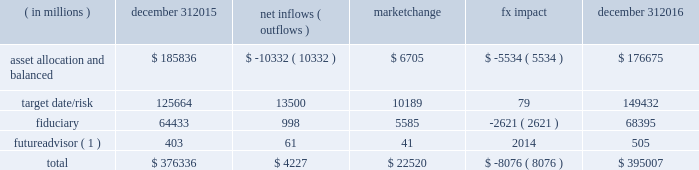Long-term product offerings include active and index strategies .
Our active strategies seek to earn attractive returns in excess of a market benchmark or performance hurdle while maintaining an appropriate risk profile .
We offer two types of active strategies : those that rely primarily on fundamental research and those that utilize primarily quantitative models to drive portfolio construction .
In contrast , index strategies seek to closely track the returns of a corresponding index , generally by investing in substantially the same underlying securities within the index or in a subset of those securities selected to approximate a similar risk and return profile of the index .
Index strategies include both our non-etf index products and ishares etfs .
Although many clients use both active and index strategies , the application of these strategies may differ .
For example , clients may use index products to gain exposure to a market or asset class , or may use a combination of index strategies to target active returns .
In addition , institutional non-etf index assignments tend to be very large ( multi-billion dollars ) and typically reflect low fee rates .
This has the potential to exaggerate the significance of net flows in institutional index products on blackrock 2019s revenues and earnings .
Equity year-end 2016 equity aum totaled $ 2.657 trillion , reflecting net inflows of $ 51.4 billion .
Net inflows included $ 74.9 billion into ishares , driven by net inflows into the core ranges and broad developed and emerging market equities .
Ishares net inflows were partially offset by active and non-etf index net outflows of $ 20.2 billion and $ 3.3 billion , respectively .
Blackrock 2019s effective fee rates fluctuate due to changes in aum mix .
Approximately half of blackrock 2019s equity aum is tied to international markets , including emerging markets , which tend to have higher fee rates than u.s .
Equity strategies .
Accordingly , fluctuations in international equity markets , which may not consistently move in tandem with u.s .
Markets , have a greater impact on blackrock 2019s effective equity fee rates and revenues .
Fixed income fixed income aum ended 2016 at $ 1.572 trillion , reflecting net inflows of $ 120.0 billion .
In 2016 , active net inflows of $ 16.6 billion were diversified across fixed income offerings , and included strong inflows from insurance clients .
Fixed income ishares net inflows of $ 59.9 billion were led by flows into the core ranges , emerging market , high yield and corporate bond funds .
Non-etf index net inflows of $ 43.4 billion were driven by demand for liability-driven investment solutions .
Multi-asset blackrock 2019s multi-asset team manages a variety of balanced funds and bespoke mandates for a diversified client base that leverages our broad investment expertise in global equities , bonds , currencies and commodities , and our extensive risk management capabilities .
Investment solutions might include a combination of long-only portfolios and alternative investments as well as tactical asset allocation overlays .
Component changes in multi-asset aum for 2016 are presented below .
( in millions ) december 31 , net inflows ( outflows ) market change impact december 31 .
( 1 ) the futureadvisor amount does not include aum that was held in ishares holdings .
Multi-asset net inflows reflected ongoing institutional demand for our solutions-based advice with $ 13.2 billion of net inflows coming from institutional clients .
Defined contribution plans of institutional clients remained a significant driver of flows , and contributed $ 11.3 billion to institutional multi-asset net inflows in 2016 , primarily into target date and target risk product offerings .
Retail net outflows of $ 9.4 billion were primarily due to outflows from world allocation strategies .
The company 2019s multi-asset strategies include the following : 2022 asset allocation and balanced products represented 45% ( 45 % ) of multi-asset aum at year-end .
These strategies combine equity , fixed income and alternative components for investors seeking a tailored solution relative to a specific benchmark and within a risk budget .
In certain cases , these strategies seek to minimize downside risk through diversification , derivatives strategies and tactical asset allocation decisions .
Flagship products in this category include our global allocation and multi-asset income fund families .
2022 target date and target risk products grew 11% ( 11 % ) organically in 2016 , with net inflows of $ 13.5 billion .
Institutional investors represented 94% ( 94 % ) of target date and target risk aum , with defined contribution plans accounting for 88% ( 88 % ) of aum .
Flows were driven by defined contribution investments in our lifepath and lifepath retirement income ae offerings .
Lifepath products utilize a proprietary asset allocation model that seeks to balance risk and return over an investment horizon based on the investor 2019s expected retirement timing .
2022 fiduciary management services are complex mandates in which pension plan sponsors or endowments and foundations retain blackrock to assume responsibility for some or all aspects of plan management .
These customized services require strong partnership with the clients 2019 investment staff and trustees in order to tailor investment strategies to meet client-specific risk budgets and return objectives. .
What is the asset allocation and balanced as a percentage of the total component changes in multi-asset aum in 2015? 
Computations: (185836 / 376336)
Answer: 0.4938. Long-term product offerings include active and index strategies .
Our active strategies seek to earn attractive returns in excess of a market benchmark or performance hurdle while maintaining an appropriate risk profile .
We offer two types of active strategies : those that rely primarily on fundamental research and those that utilize primarily quantitative models to drive portfolio construction .
In contrast , index strategies seek to closely track the returns of a corresponding index , generally by investing in substantially the same underlying securities within the index or in a subset of those securities selected to approximate a similar risk and return profile of the index .
Index strategies include both our non-etf index products and ishares etfs .
Although many clients use both active and index strategies , the application of these strategies may differ .
For example , clients may use index products to gain exposure to a market or asset class , or may use a combination of index strategies to target active returns .
In addition , institutional non-etf index assignments tend to be very large ( multi-billion dollars ) and typically reflect low fee rates .
This has the potential to exaggerate the significance of net flows in institutional index products on blackrock 2019s revenues and earnings .
Equity year-end 2016 equity aum totaled $ 2.657 trillion , reflecting net inflows of $ 51.4 billion .
Net inflows included $ 74.9 billion into ishares , driven by net inflows into the core ranges and broad developed and emerging market equities .
Ishares net inflows were partially offset by active and non-etf index net outflows of $ 20.2 billion and $ 3.3 billion , respectively .
Blackrock 2019s effective fee rates fluctuate due to changes in aum mix .
Approximately half of blackrock 2019s equity aum is tied to international markets , including emerging markets , which tend to have higher fee rates than u.s .
Equity strategies .
Accordingly , fluctuations in international equity markets , which may not consistently move in tandem with u.s .
Markets , have a greater impact on blackrock 2019s effective equity fee rates and revenues .
Fixed income fixed income aum ended 2016 at $ 1.572 trillion , reflecting net inflows of $ 120.0 billion .
In 2016 , active net inflows of $ 16.6 billion were diversified across fixed income offerings , and included strong inflows from insurance clients .
Fixed income ishares net inflows of $ 59.9 billion were led by flows into the core ranges , emerging market , high yield and corporate bond funds .
Non-etf index net inflows of $ 43.4 billion were driven by demand for liability-driven investment solutions .
Multi-asset blackrock 2019s multi-asset team manages a variety of balanced funds and bespoke mandates for a diversified client base that leverages our broad investment expertise in global equities , bonds , currencies and commodities , and our extensive risk management capabilities .
Investment solutions might include a combination of long-only portfolios and alternative investments as well as tactical asset allocation overlays .
Component changes in multi-asset aum for 2016 are presented below .
( in millions ) december 31 , net inflows ( outflows ) market change impact december 31 .
( 1 ) the futureadvisor amount does not include aum that was held in ishares holdings .
Multi-asset net inflows reflected ongoing institutional demand for our solutions-based advice with $ 13.2 billion of net inflows coming from institutional clients .
Defined contribution plans of institutional clients remained a significant driver of flows , and contributed $ 11.3 billion to institutional multi-asset net inflows in 2016 , primarily into target date and target risk product offerings .
Retail net outflows of $ 9.4 billion were primarily due to outflows from world allocation strategies .
The company 2019s multi-asset strategies include the following : 2022 asset allocation and balanced products represented 45% ( 45 % ) of multi-asset aum at year-end .
These strategies combine equity , fixed income and alternative components for investors seeking a tailored solution relative to a specific benchmark and within a risk budget .
In certain cases , these strategies seek to minimize downside risk through diversification , derivatives strategies and tactical asset allocation decisions .
Flagship products in this category include our global allocation and multi-asset income fund families .
2022 target date and target risk products grew 11% ( 11 % ) organically in 2016 , with net inflows of $ 13.5 billion .
Institutional investors represented 94% ( 94 % ) of target date and target risk aum , with defined contribution plans accounting for 88% ( 88 % ) of aum .
Flows were driven by defined contribution investments in our lifepath and lifepath retirement income ae offerings .
Lifepath products utilize a proprietary asset allocation model that seeks to balance risk and return over an investment horizon based on the investor 2019s expected retirement timing .
2022 fiduciary management services are complex mandates in which pension plan sponsors or endowments and foundations retain blackrock to assume responsibility for some or all aspects of plan management .
These customized services require strong partnership with the clients 2019 investment staff and trustees in order to tailor investment strategies to meet client-specific risk budgets and return objectives. .
What is the percent change in target date/risk from december 31 , 2015 to december 31 , 2016? 
Computations: ((149432 - 125664) / 125664)
Answer: 0.18914. Long-term product offerings include active and index strategies .
Our active strategies seek to earn attractive returns in excess of a market benchmark or performance hurdle while maintaining an appropriate risk profile .
We offer two types of active strategies : those that rely primarily on fundamental research and those that utilize primarily quantitative models to drive portfolio construction .
In contrast , index strategies seek to closely track the returns of a corresponding index , generally by investing in substantially the same underlying securities within the index or in a subset of those securities selected to approximate a similar risk and return profile of the index .
Index strategies include both our non-etf index products and ishares etfs .
Although many clients use both active and index strategies , the application of these strategies may differ .
For example , clients may use index products to gain exposure to a market or asset class , or may use a combination of index strategies to target active returns .
In addition , institutional non-etf index assignments tend to be very large ( multi-billion dollars ) and typically reflect low fee rates .
This has the potential to exaggerate the significance of net flows in institutional index products on blackrock 2019s revenues and earnings .
Equity year-end 2016 equity aum totaled $ 2.657 trillion , reflecting net inflows of $ 51.4 billion .
Net inflows included $ 74.9 billion into ishares , driven by net inflows into the core ranges and broad developed and emerging market equities .
Ishares net inflows were partially offset by active and non-etf index net outflows of $ 20.2 billion and $ 3.3 billion , respectively .
Blackrock 2019s effective fee rates fluctuate due to changes in aum mix .
Approximately half of blackrock 2019s equity aum is tied to international markets , including emerging markets , which tend to have higher fee rates than u.s .
Equity strategies .
Accordingly , fluctuations in international equity markets , which may not consistently move in tandem with u.s .
Markets , have a greater impact on blackrock 2019s effective equity fee rates and revenues .
Fixed income fixed income aum ended 2016 at $ 1.572 trillion , reflecting net inflows of $ 120.0 billion .
In 2016 , active net inflows of $ 16.6 billion were diversified across fixed income offerings , and included strong inflows from insurance clients .
Fixed income ishares net inflows of $ 59.9 billion were led by flows into the core ranges , emerging market , high yield and corporate bond funds .
Non-etf index net inflows of $ 43.4 billion were driven by demand for liability-driven investment solutions .
Multi-asset blackrock 2019s multi-asset team manages a variety of balanced funds and bespoke mandates for a diversified client base that leverages our broad investment expertise in global equities , bonds , currencies and commodities , and our extensive risk management capabilities .
Investment solutions might include a combination of long-only portfolios and alternative investments as well as tactical asset allocation overlays .
Component changes in multi-asset aum for 2016 are presented below .
( in millions ) december 31 , net inflows ( outflows ) market change impact december 31 .
( 1 ) the futureadvisor amount does not include aum that was held in ishares holdings .
Multi-asset net inflows reflected ongoing institutional demand for our solutions-based advice with $ 13.2 billion of net inflows coming from institutional clients .
Defined contribution plans of institutional clients remained a significant driver of flows , and contributed $ 11.3 billion to institutional multi-asset net inflows in 2016 , primarily into target date and target risk product offerings .
Retail net outflows of $ 9.4 billion were primarily due to outflows from world allocation strategies .
The company 2019s multi-asset strategies include the following : 2022 asset allocation and balanced products represented 45% ( 45 % ) of multi-asset aum at year-end .
These strategies combine equity , fixed income and alternative components for investors seeking a tailored solution relative to a specific benchmark and within a risk budget .
In certain cases , these strategies seek to minimize downside risk through diversification , derivatives strategies and tactical asset allocation decisions .
Flagship products in this category include our global allocation and multi-asset income fund families .
2022 target date and target risk products grew 11% ( 11 % ) organically in 2016 , with net inflows of $ 13.5 billion .
Institutional investors represented 94% ( 94 % ) of target date and target risk aum , with defined contribution plans accounting for 88% ( 88 % ) of aum .
Flows were driven by defined contribution investments in our lifepath and lifepath retirement income ae offerings .
Lifepath products utilize a proprietary asset allocation model that seeks to balance risk and return over an investment horizon based on the investor 2019s expected retirement timing .
2022 fiduciary management services are complex mandates in which pension plan sponsors or endowments and foundations retain blackrock to assume responsibility for some or all aspects of plan management .
These customized services require strong partnership with the clients 2019 investment staff and trustees in order to tailor investment strategies to meet client-specific risk budgets and return objectives. .
What portion of total net multi-asset aum inflows is related to target date/risk as of december 31 , 2016? 
Computations: (149432 / 395007)
Answer: 0.3783. 